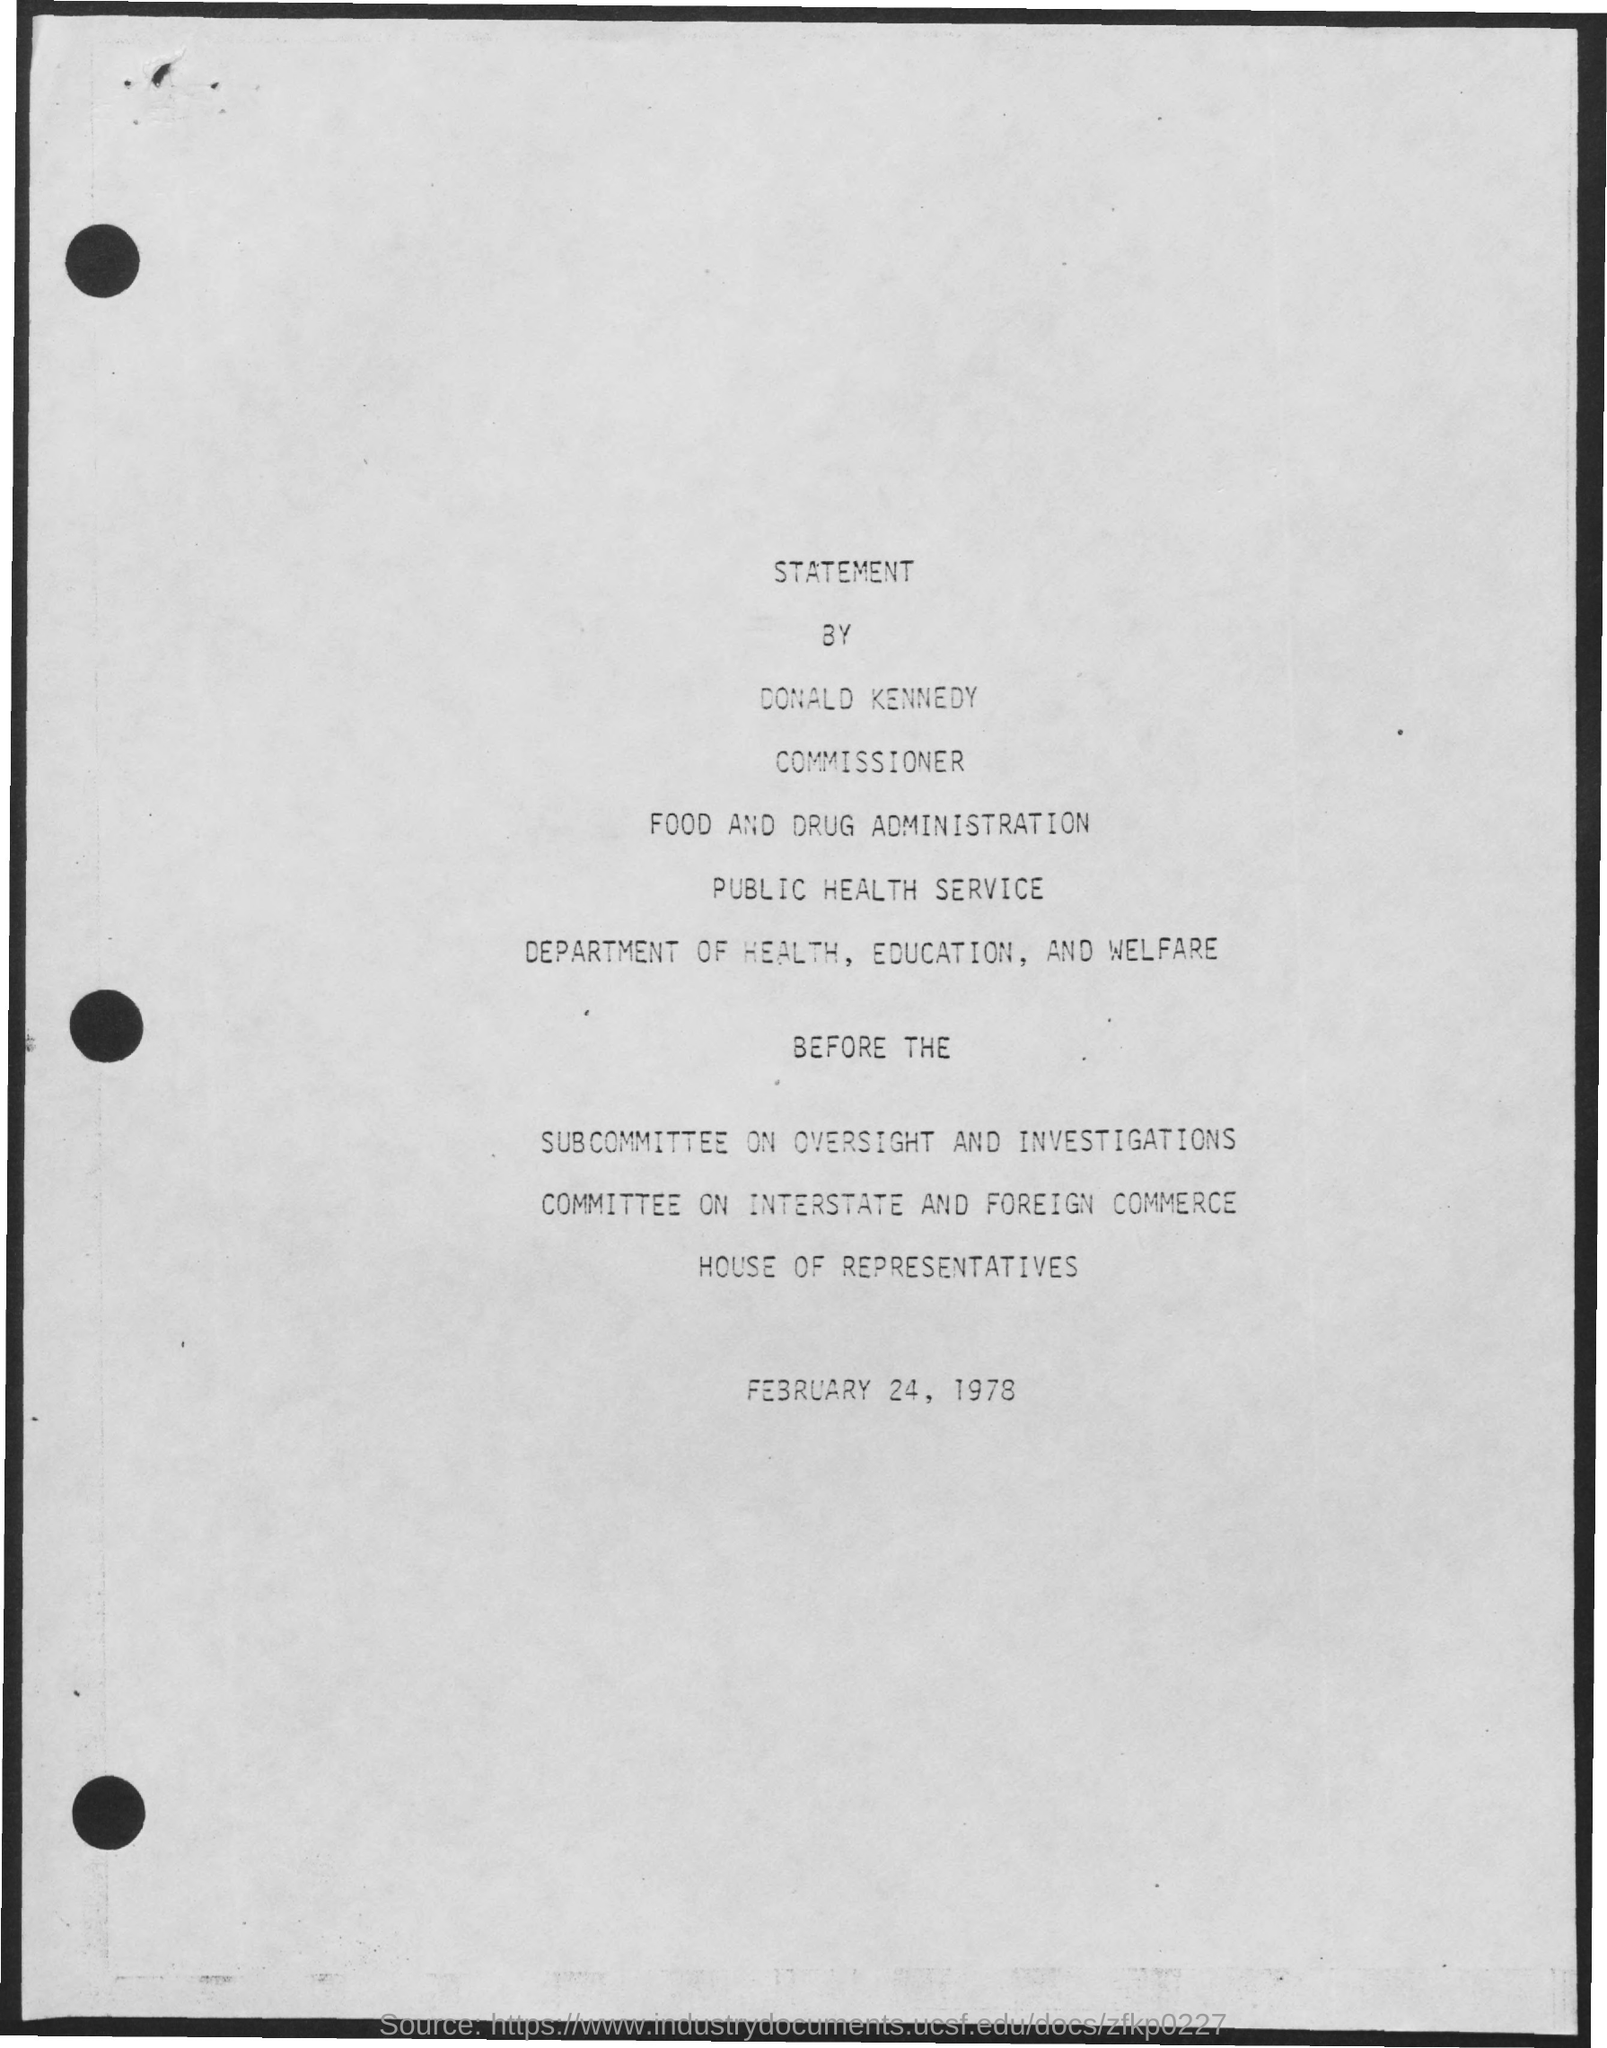What is the date mentioned in the document?
Provide a short and direct response. February 24, 1978. 